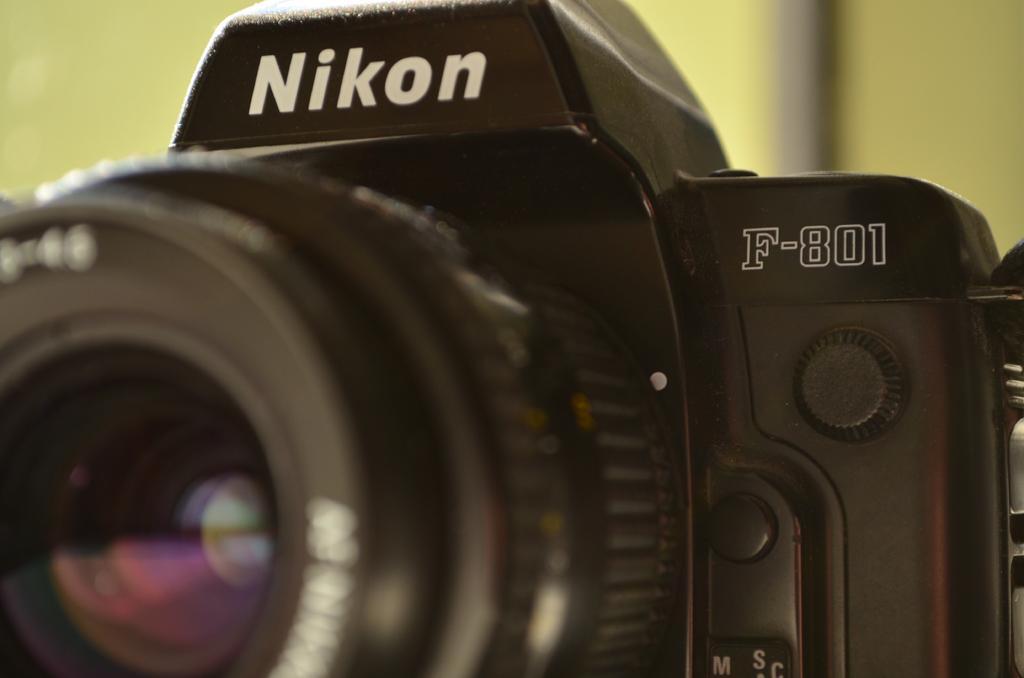How would you summarize this image in a sentence or two? In this picture I can see a camera and I can see text on the camera and I can see blurry background. 